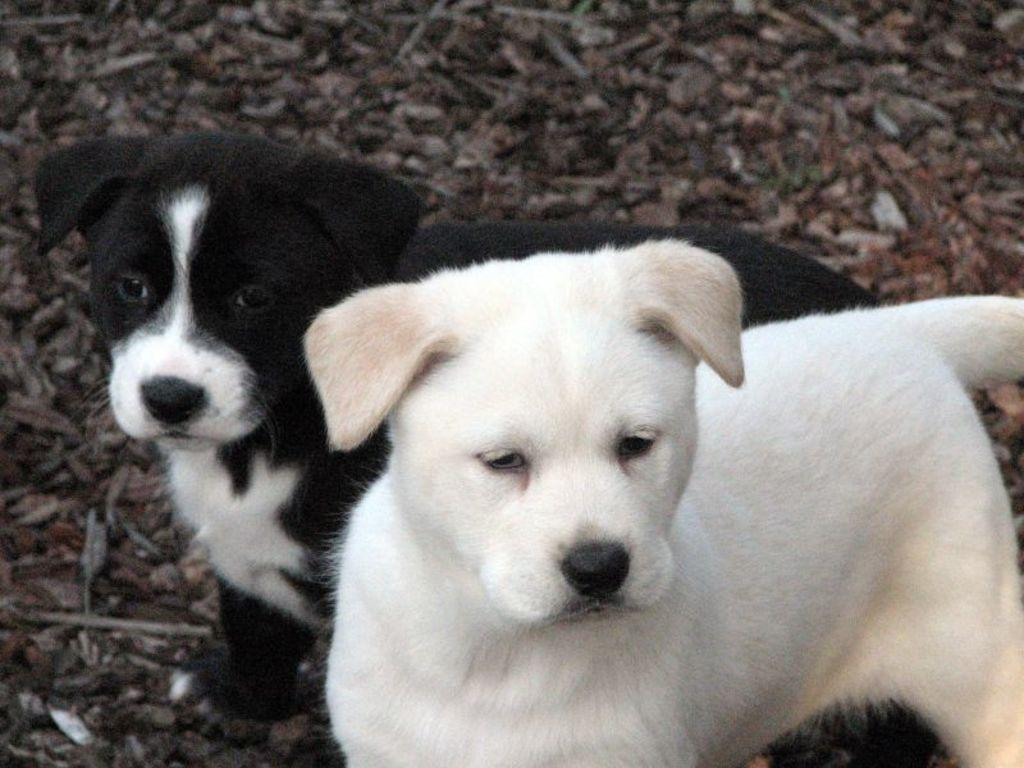What is located in the foreground of the picture? There are dogs and stones in the foreground of the picture. Can you describe the stones in the foreground? The stones in the foreground are visible alongside the dogs. Are there any stones in other parts of the picture? Yes, there are stones at the top of the picture. What type of loaf can be seen in the picture? There is no loaf present in the picture; it features dogs and stones. How many sticks are visible in the picture? There are no sticks visible in the picture. 